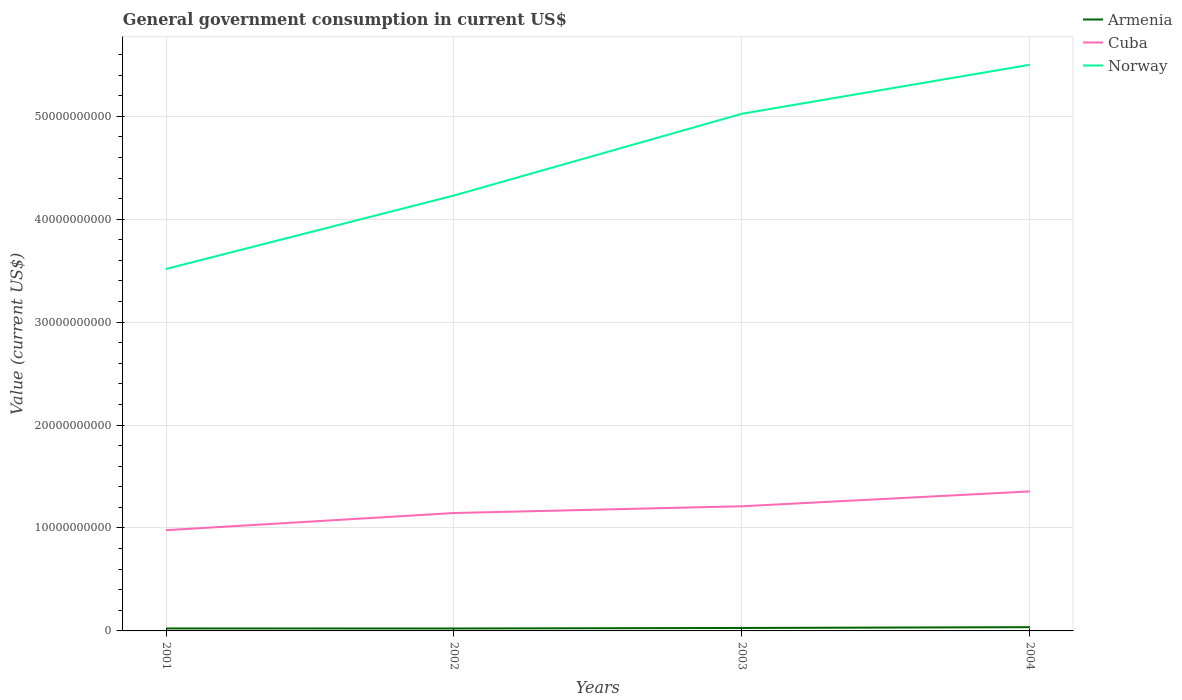Is the number of lines equal to the number of legend labels?
Keep it short and to the point. Yes. Across all years, what is the maximum government conusmption in Armenia?
Your answer should be compact. 2.37e+08. What is the total government conusmption in Norway in the graph?
Your answer should be compact. -7.94e+09. What is the difference between the highest and the second highest government conusmption in Norway?
Make the answer very short. 1.98e+1. How many lines are there?
Give a very brief answer. 3. How many years are there in the graph?
Give a very brief answer. 4. Are the values on the major ticks of Y-axis written in scientific E-notation?
Ensure brevity in your answer.  No. Does the graph contain any zero values?
Make the answer very short. No. Does the graph contain grids?
Provide a succinct answer. Yes. How are the legend labels stacked?
Keep it short and to the point. Vertical. What is the title of the graph?
Offer a very short reply. General government consumption in current US$. What is the label or title of the X-axis?
Offer a terse response. Years. What is the label or title of the Y-axis?
Your response must be concise. Value (current US$). What is the Value (current US$) of Armenia in 2001?
Provide a succinct answer. 2.39e+08. What is the Value (current US$) of Cuba in 2001?
Keep it short and to the point. 9.79e+09. What is the Value (current US$) of Norway in 2001?
Make the answer very short. 3.52e+1. What is the Value (current US$) in Armenia in 2002?
Your answer should be compact. 2.37e+08. What is the Value (current US$) of Cuba in 2002?
Give a very brief answer. 1.15e+1. What is the Value (current US$) of Norway in 2002?
Provide a short and direct response. 4.23e+1. What is the Value (current US$) of Armenia in 2003?
Keep it short and to the point. 2.87e+08. What is the Value (current US$) in Cuba in 2003?
Offer a very short reply. 1.21e+1. What is the Value (current US$) of Norway in 2003?
Offer a terse response. 5.02e+1. What is the Value (current US$) in Armenia in 2004?
Give a very brief answer. 3.64e+08. What is the Value (current US$) of Cuba in 2004?
Provide a succinct answer. 1.36e+1. What is the Value (current US$) of Norway in 2004?
Your response must be concise. 5.50e+1. Across all years, what is the maximum Value (current US$) of Armenia?
Your answer should be compact. 3.64e+08. Across all years, what is the maximum Value (current US$) of Cuba?
Provide a short and direct response. 1.36e+1. Across all years, what is the maximum Value (current US$) of Norway?
Your answer should be compact. 5.50e+1. Across all years, what is the minimum Value (current US$) in Armenia?
Ensure brevity in your answer.  2.37e+08. Across all years, what is the minimum Value (current US$) of Cuba?
Your response must be concise. 9.79e+09. Across all years, what is the minimum Value (current US$) in Norway?
Ensure brevity in your answer.  3.52e+1. What is the total Value (current US$) of Armenia in the graph?
Offer a terse response. 1.13e+09. What is the total Value (current US$) of Cuba in the graph?
Keep it short and to the point. 4.69e+1. What is the total Value (current US$) in Norway in the graph?
Your answer should be very brief. 1.83e+11. What is the difference between the Value (current US$) in Armenia in 2001 and that in 2002?
Give a very brief answer. 1.76e+06. What is the difference between the Value (current US$) of Cuba in 2001 and that in 2002?
Give a very brief answer. -1.67e+09. What is the difference between the Value (current US$) of Norway in 2001 and that in 2002?
Your answer should be very brief. -7.14e+09. What is the difference between the Value (current US$) of Armenia in 2001 and that in 2003?
Offer a terse response. -4.74e+07. What is the difference between the Value (current US$) in Cuba in 2001 and that in 2003?
Make the answer very short. -2.32e+09. What is the difference between the Value (current US$) in Norway in 2001 and that in 2003?
Offer a very short reply. -1.51e+1. What is the difference between the Value (current US$) in Armenia in 2001 and that in 2004?
Ensure brevity in your answer.  -1.25e+08. What is the difference between the Value (current US$) in Cuba in 2001 and that in 2004?
Provide a succinct answer. -3.77e+09. What is the difference between the Value (current US$) in Norway in 2001 and that in 2004?
Your answer should be very brief. -1.98e+1. What is the difference between the Value (current US$) in Armenia in 2002 and that in 2003?
Your answer should be very brief. -4.92e+07. What is the difference between the Value (current US$) in Cuba in 2002 and that in 2003?
Make the answer very short. -6.55e+08. What is the difference between the Value (current US$) of Norway in 2002 and that in 2003?
Offer a terse response. -7.94e+09. What is the difference between the Value (current US$) of Armenia in 2002 and that in 2004?
Make the answer very short. -1.27e+08. What is the difference between the Value (current US$) in Cuba in 2002 and that in 2004?
Provide a short and direct response. -2.10e+09. What is the difference between the Value (current US$) in Norway in 2002 and that in 2004?
Keep it short and to the point. -1.27e+1. What is the difference between the Value (current US$) of Armenia in 2003 and that in 2004?
Your answer should be compact. -7.73e+07. What is the difference between the Value (current US$) in Cuba in 2003 and that in 2004?
Offer a very short reply. -1.44e+09. What is the difference between the Value (current US$) of Norway in 2003 and that in 2004?
Offer a very short reply. -4.76e+09. What is the difference between the Value (current US$) of Armenia in 2001 and the Value (current US$) of Cuba in 2002?
Give a very brief answer. -1.12e+1. What is the difference between the Value (current US$) in Armenia in 2001 and the Value (current US$) in Norway in 2002?
Make the answer very short. -4.21e+1. What is the difference between the Value (current US$) of Cuba in 2001 and the Value (current US$) of Norway in 2002?
Give a very brief answer. -3.25e+1. What is the difference between the Value (current US$) of Armenia in 2001 and the Value (current US$) of Cuba in 2003?
Offer a terse response. -1.19e+1. What is the difference between the Value (current US$) in Armenia in 2001 and the Value (current US$) in Norway in 2003?
Your answer should be compact. -5.00e+1. What is the difference between the Value (current US$) in Cuba in 2001 and the Value (current US$) in Norway in 2003?
Provide a short and direct response. -4.05e+1. What is the difference between the Value (current US$) of Armenia in 2001 and the Value (current US$) of Cuba in 2004?
Your response must be concise. -1.33e+1. What is the difference between the Value (current US$) of Armenia in 2001 and the Value (current US$) of Norway in 2004?
Ensure brevity in your answer.  -5.48e+1. What is the difference between the Value (current US$) in Cuba in 2001 and the Value (current US$) in Norway in 2004?
Offer a very short reply. -4.52e+1. What is the difference between the Value (current US$) of Armenia in 2002 and the Value (current US$) of Cuba in 2003?
Ensure brevity in your answer.  -1.19e+1. What is the difference between the Value (current US$) in Armenia in 2002 and the Value (current US$) in Norway in 2003?
Your answer should be compact. -5.00e+1. What is the difference between the Value (current US$) in Cuba in 2002 and the Value (current US$) in Norway in 2003?
Your answer should be compact. -3.88e+1. What is the difference between the Value (current US$) in Armenia in 2002 and the Value (current US$) in Cuba in 2004?
Give a very brief answer. -1.33e+1. What is the difference between the Value (current US$) of Armenia in 2002 and the Value (current US$) of Norway in 2004?
Your answer should be very brief. -5.48e+1. What is the difference between the Value (current US$) of Cuba in 2002 and the Value (current US$) of Norway in 2004?
Keep it short and to the point. -4.36e+1. What is the difference between the Value (current US$) of Armenia in 2003 and the Value (current US$) of Cuba in 2004?
Keep it short and to the point. -1.33e+1. What is the difference between the Value (current US$) of Armenia in 2003 and the Value (current US$) of Norway in 2004?
Give a very brief answer. -5.47e+1. What is the difference between the Value (current US$) of Cuba in 2003 and the Value (current US$) of Norway in 2004?
Keep it short and to the point. -4.29e+1. What is the average Value (current US$) in Armenia per year?
Provide a succinct answer. 2.82e+08. What is the average Value (current US$) of Cuba per year?
Ensure brevity in your answer.  1.17e+1. What is the average Value (current US$) in Norway per year?
Your answer should be very brief. 4.57e+1. In the year 2001, what is the difference between the Value (current US$) in Armenia and Value (current US$) in Cuba?
Your response must be concise. -9.55e+09. In the year 2001, what is the difference between the Value (current US$) of Armenia and Value (current US$) of Norway?
Offer a terse response. -3.49e+1. In the year 2001, what is the difference between the Value (current US$) in Cuba and Value (current US$) in Norway?
Your response must be concise. -2.54e+1. In the year 2002, what is the difference between the Value (current US$) in Armenia and Value (current US$) in Cuba?
Provide a succinct answer. -1.12e+1. In the year 2002, what is the difference between the Value (current US$) in Armenia and Value (current US$) in Norway?
Provide a succinct answer. -4.21e+1. In the year 2002, what is the difference between the Value (current US$) in Cuba and Value (current US$) in Norway?
Give a very brief answer. -3.08e+1. In the year 2003, what is the difference between the Value (current US$) in Armenia and Value (current US$) in Cuba?
Give a very brief answer. -1.18e+1. In the year 2003, what is the difference between the Value (current US$) of Armenia and Value (current US$) of Norway?
Your response must be concise. -5.00e+1. In the year 2003, what is the difference between the Value (current US$) of Cuba and Value (current US$) of Norway?
Provide a short and direct response. -3.81e+1. In the year 2004, what is the difference between the Value (current US$) in Armenia and Value (current US$) in Cuba?
Ensure brevity in your answer.  -1.32e+1. In the year 2004, what is the difference between the Value (current US$) in Armenia and Value (current US$) in Norway?
Your answer should be compact. -5.46e+1. In the year 2004, what is the difference between the Value (current US$) of Cuba and Value (current US$) of Norway?
Offer a very short reply. -4.15e+1. What is the ratio of the Value (current US$) in Armenia in 2001 to that in 2002?
Offer a very short reply. 1.01. What is the ratio of the Value (current US$) of Cuba in 2001 to that in 2002?
Your answer should be very brief. 0.85. What is the ratio of the Value (current US$) in Norway in 2001 to that in 2002?
Offer a very short reply. 0.83. What is the ratio of the Value (current US$) in Armenia in 2001 to that in 2003?
Offer a very short reply. 0.83. What is the ratio of the Value (current US$) in Cuba in 2001 to that in 2003?
Your response must be concise. 0.81. What is the ratio of the Value (current US$) of Norway in 2001 to that in 2003?
Your response must be concise. 0.7. What is the ratio of the Value (current US$) in Armenia in 2001 to that in 2004?
Your response must be concise. 0.66. What is the ratio of the Value (current US$) of Cuba in 2001 to that in 2004?
Make the answer very short. 0.72. What is the ratio of the Value (current US$) of Norway in 2001 to that in 2004?
Provide a succinct answer. 0.64. What is the ratio of the Value (current US$) of Armenia in 2002 to that in 2003?
Your answer should be very brief. 0.83. What is the ratio of the Value (current US$) of Cuba in 2002 to that in 2003?
Your response must be concise. 0.95. What is the ratio of the Value (current US$) of Norway in 2002 to that in 2003?
Provide a short and direct response. 0.84. What is the ratio of the Value (current US$) in Armenia in 2002 to that in 2004?
Offer a terse response. 0.65. What is the ratio of the Value (current US$) in Cuba in 2002 to that in 2004?
Keep it short and to the point. 0.85. What is the ratio of the Value (current US$) in Norway in 2002 to that in 2004?
Your answer should be very brief. 0.77. What is the ratio of the Value (current US$) in Armenia in 2003 to that in 2004?
Offer a terse response. 0.79. What is the ratio of the Value (current US$) of Cuba in 2003 to that in 2004?
Keep it short and to the point. 0.89. What is the ratio of the Value (current US$) in Norway in 2003 to that in 2004?
Make the answer very short. 0.91. What is the difference between the highest and the second highest Value (current US$) in Armenia?
Your answer should be very brief. 7.73e+07. What is the difference between the highest and the second highest Value (current US$) of Cuba?
Offer a very short reply. 1.44e+09. What is the difference between the highest and the second highest Value (current US$) in Norway?
Ensure brevity in your answer.  4.76e+09. What is the difference between the highest and the lowest Value (current US$) in Armenia?
Keep it short and to the point. 1.27e+08. What is the difference between the highest and the lowest Value (current US$) of Cuba?
Your response must be concise. 3.77e+09. What is the difference between the highest and the lowest Value (current US$) in Norway?
Provide a short and direct response. 1.98e+1. 